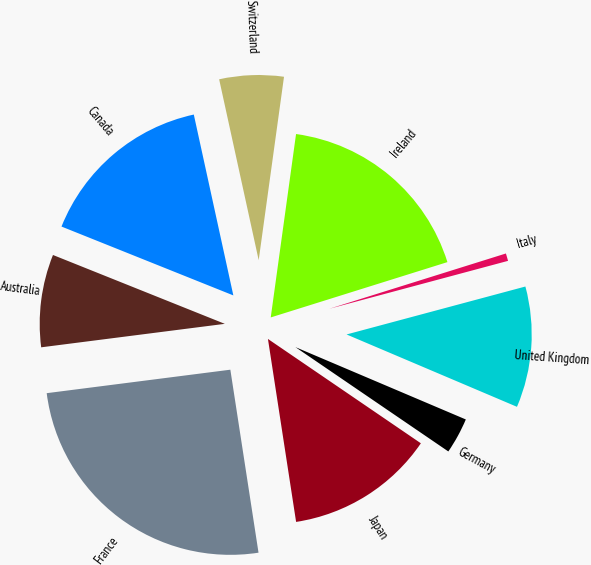<chart> <loc_0><loc_0><loc_500><loc_500><pie_chart><fcel>France<fcel>Japan<fcel>Germany<fcel>United Kingdom<fcel>Italy<fcel>Ireland<fcel>Switzerland<fcel>Canada<fcel>Australia<nl><fcel>25.41%<fcel>13.04%<fcel>3.14%<fcel>10.56%<fcel>0.66%<fcel>17.99%<fcel>5.61%<fcel>15.51%<fcel>8.09%<nl></chart> 